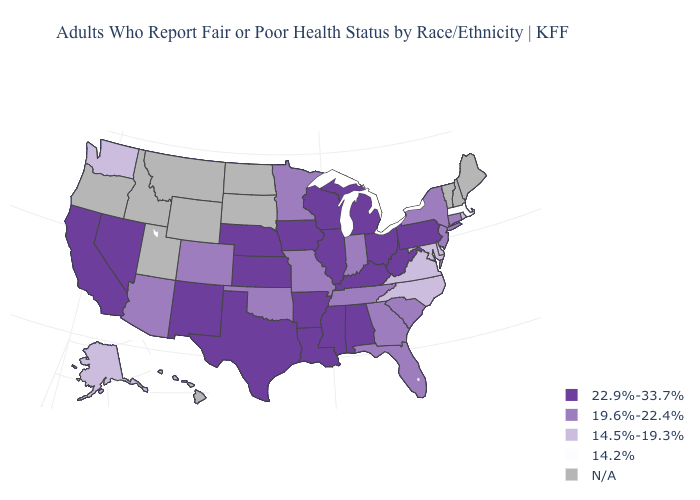Name the states that have a value in the range 14.5%-19.3%?
Write a very short answer. Alaska, Delaware, Maryland, North Carolina, Rhode Island, Virginia, Washington. What is the value of North Dakota?
Quick response, please. N/A. Among the states that border Wyoming , does Nebraska have the highest value?
Be succinct. Yes. Name the states that have a value in the range 14.2%?
Quick response, please. Massachusetts. Does Iowa have the lowest value in the MidWest?
Concise answer only. No. What is the highest value in the USA?
Write a very short answer. 22.9%-33.7%. Does Massachusetts have the lowest value in the USA?
Write a very short answer. Yes. Does the first symbol in the legend represent the smallest category?
Short answer required. No. Name the states that have a value in the range 14.2%?
Quick response, please. Massachusetts. Among the states that border Iowa , which have the lowest value?
Answer briefly. Minnesota, Missouri. Name the states that have a value in the range N/A?
Short answer required. Hawaii, Idaho, Maine, Montana, New Hampshire, North Dakota, Oregon, South Dakota, Utah, Vermont, Wyoming. What is the value of Connecticut?
Be succinct. 19.6%-22.4%. 